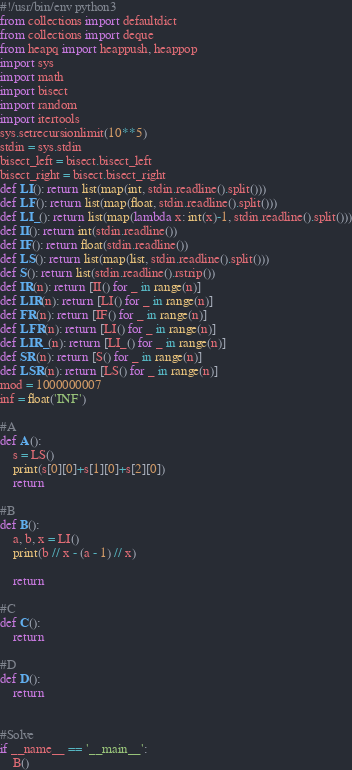Convert code to text. <code><loc_0><loc_0><loc_500><loc_500><_Python_>#!/usr/bin/env python3
from collections import defaultdict
from collections import deque
from heapq import heappush, heappop
import sys
import math
import bisect
import random
import itertools
sys.setrecursionlimit(10**5)
stdin = sys.stdin
bisect_left = bisect.bisect_left
bisect_right = bisect.bisect_right
def LI(): return list(map(int, stdin.readline().split()))
def LF(): return list(map(float, stdin.readline().split()))
def LI_(): return list(map(lambda x: int(x)-1, stdin.readline().split()))
def II(): return int(stdin.readline())
def IF(): return float(stdin.readline())
def LS(): return list(map(list, stdin.readline().split()))
def S(): return list(stdin.readline().rstrip())
def IR(n): return [II() for _ in range(n)]
def LIR(n): return [LI() for _ in range(n)]
def FR(n): return [IF() for _ in range(n)]
def LFR(n): return [LI() for _ in range(n)]
def LIR_(n): return [LI_() for _ in range(n)]
def SR(n): return [S() for _ in range(n)]
def LSR(n): return [LS() for _ in range(n)]
mod = 1000000007
inf = float('INF')

#A
def A():
    s = LS()
    print(s[0][0]+s[1][0]+s[2][0])
    return

#B
def B():
    a, b, x = LI()
    print(b // x - (a - 1) // x)
    
    return

#C
def C():
    return

#D
def D():
    return


#Solve
if __name__ == '__main__':
    B()
</code> 